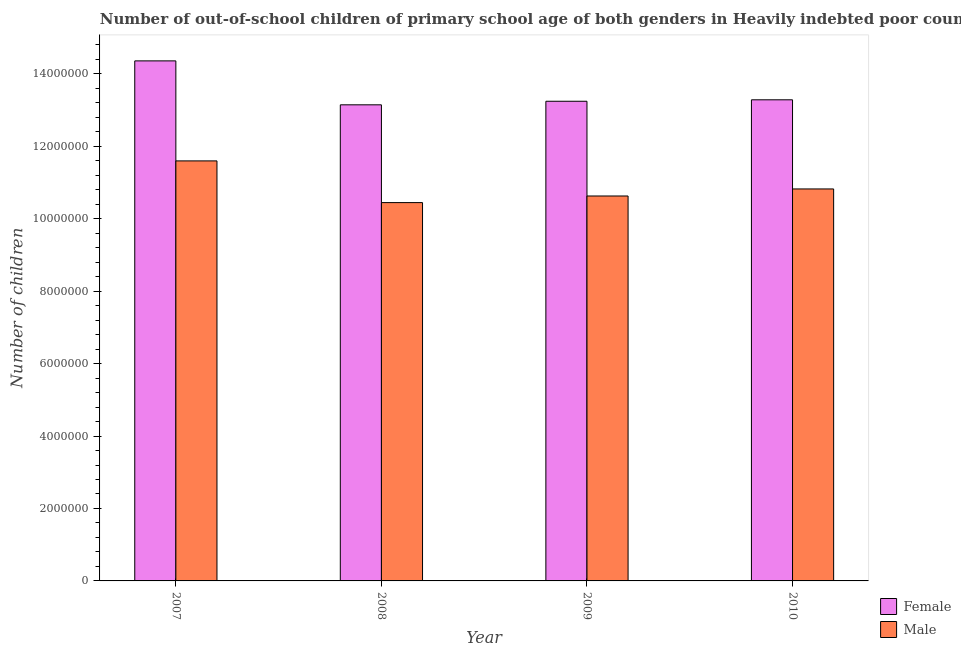How many groups of bars are there?
Offer a very short reply. 4. Are the number of bars per tick equal to the number of legend labels?
Keep it short and to the point. Yes. Are the number of bars on each tick of the X-axis equal?
Your answer should be compact. Yes. How many bars are there on the 3rd tick from the left?
Give a very brief answer. 2. What is the number of male out-of-school students in 2009?
Give a very brief answer. 1.06e+07. Across all years, what is the maximum number of male out-of-school students?
Make the answer very short. 1.16e+07. Across all years, what is the minimum number of male out-of-school students?
Offer a terse response. 1.04e+07. In which year was the number of male out-of-school students maximum?
Make the answer very short. 2007. What is the total number of female out-of-school students in the graph?
Offer a terse response. 5.40e+07. What is the difference between the number of male out-of-school students in 2007 and that in 2008?
Your response must be concise. 1.15e+06. What is the difference between the number of female out-of-school students in 2008 and the number of male out-of-school students in 2009?
Your answer should be very brief. -9.85e+04. What is the average number of female out-of-school students per year?
Provide a short and direct response. 1.35e+07. In the year 2008, what is the difference between the number of male out-of-school students and number of female out-of-school students?
Your response must be concise. 0. In how many years, is the number of female out-of-school students greater than 400000?
Ensure brevity in your answer.  4. What is the ratio of the number of male out-of-school students in 2007 to that in 2008?
Your answer should be very brief. 1.11. What is the difference between the highest and the second highest number of male out-of-school students?
Give a very brief answer. 7.74e+05. What is the difference between the highest and the lowest number of female out-of-school students?
Provide a short and direct response. 1.21e+06. In how many years, is the number of male out-of-school students greater than the average number of male out-of-school students taken over all years?
Make the answer very short. 1. Is the sum of the number of male out-of-school students in 2008 and 2009 greater than the maximum number of female out-of-school students across all years?
Make the answer very short. Yes. What does the 1st bar from the left in 2010 represents?
Your response must be concise. Female. How many bars are there?
Your answer should be compact. 8. How many years are there in the graph?
Provide a short and direct response. 4. What is the difference between two consecutive major ticks on the Y-axis?
Provide a succinct answer. 2.00e+06. Where does the legend appear in the graph?
Make the answer very short. Bottom right. What is the title of the graph?
Keep it short and to the point. Number of out-of-school children of primary school age of both genders in Heavily indebted poor countries. What is the label or title of the X-axis?
Ensure brevity in your answer.  Year. What is the label or title of the Y-axis?
Provide a succinct answer. Number of children. What is the Number of children of Female in 2007?
Keep it short and to the point. 1.44e+07. What is the Number of children of Male in 2007?
Offer a very short reply. 1.16e+07. What is the Number of children in Female in 2008?
Provide a succinct answer. 1.31e+07. What is the Number of children of Male in 2008?
Your response must be concise. 1.04e+07. What is the Number of children of Female in 2009?
Ensure brevity in your answer.  1.32e+07. What is the Number of children in Male in 2009?
Provide a short and direct response. 1.06e+07. What is the Number of children of Female in 2010?
Make the answer very short. 1.33e+07. What is the Number of children in Male in 2010?
Ensure brevity in your answer.  1.08e+07. Across all years, what is the maximum Number of children in Female?
Provide a succinct answer. 1.44e+07. Across all years, what is the maximum Number of children of Male?
Keep it short and to the point. 1.16e+07. Across all years, what is the minimum Number of children of Female?
Offer a very short reply. 1.31e+07. Across all years, what is the minimum Number of children of Male?
Give a very brief answer. 1.04e+07. What is the total Number of children of Female in the graph?
Provide a short and direct response. 5.40e+07. What is the total Number of children of Male in the graph?
Provide a short and direct response. 4.35e+07. What is the difference between the Number of children in Female in 2007 and that in 2008?
Ensure brevity in your answer.  1.21e+06. What is the difference between the Number of children of Male in 2007 and that in 2008?
Ensure brevity in your answer.  1.15e+06. What is the difference between the Number of children of Female in 2007 and that in 2009?
Keep it short and to the point. 1.11e+06. What is the difference between the Number of children of Male in 2007 and that in 2009?
Ensure brevity in your answer.  9.69e+05. What is the difference between the Number of children of Female in 2007 and that in 2010?
Offer a terse response. 1.07e+06. What is the difference between the Number of children in Male in 2007 and that in 2010?
Your response must be concise. 7.74e+05. What is the difference between the Number of children in Female in 2008 and that in 2009?
Ensure brevity in your answer.  -9.85e+04. What is the difference between the Number of children of Male in 2008 and that in 2009?
Your answer should be compact. -1.83e+05. What is the difference between the Number of children of Female in 2008 and that in 2010?
Provide a short and direct response. -1.38e+05. What is the difference between the Number of children in Male in 2008 and that in 2010?
Your answer should be very brief. -3.77e+05. What is the difference between the Number of children in Female in 2009 and that in 2010?
Keep it short and to the point. -4.00e+04. What is the difference between the Number of children in Male in 2009 and that in 2010?
Keep it short and to the point. -1.95e+05. What is the difference between the Number of children of Female in 2007 and the Number of children of Male in 2008?
Your response must be concise. 3.91e+06. What is the difference between the Number of children of Female in 2007 and the Number of children of Male in 2009?
Offer a terse response. 3.73e+06. What is the difference between the Number of children in Female in 2007 and the Number of children in Male in 2010?
Offer a very short reply. 3.54e+06. What is the difference between the Number of children of Female in 2008 and the Number of children of Male in 2009?
Offer a very short reply. 2.52e+06. What is the difference between the Number of children in Female in 2008 and the Number of children in Male in 2010?
Your answer should be very brief. 2.32e+06. What is the difference between the Number of children of Female in 2009 and the Number of children of Male in 2010?
Give a very brief answer. 2.42e+06. What is the average Number of children in Female per year?
Provide a succinct answer. 1.35e+07. What is the average Number of children of Male per year?
Your answer should be compact. 1.09e+07. In the year 2007, what is the difference between the Number of children of Female and Number of children of Male?
Provide a succinct answer. 2.76e+06. In the year 2008, what is the difference between the Number of children in Female and Number of children in Male?
Keep it short and to the point. 2.70e+06. In the year 2009, what is the difference between the Number of children of Female and Number of children of Male?
Provide a succinct answer. 2.62e+06. In the year 2010, what is the difference between the Number of children in Female and Number of children in Male?
Your response must be concise. 2.46e+06. What is the ratio of the Number of children in Female in 2007 to that in 2008?
Your answer should be compact. 1.09. What is the ratio of the Number of children of Male in 2007 to that in 2008?
Your response must be concise. 1.11. What is the ratio of the Number of children in Female in 2007 to that in 2009?
Your answer should be very brief. 1.08. What is the ratio of the Number of children of Male in 2007 to that in 2009?
Give a very brief answer. 1.09. What is the ratio of the Number of children of Female in 2007 to that in 2010?
Offer a very short reply. 1.08. What is the ratio of the Number of children in Male in 2007 to that in 2010?
Ensure brevity in your answer.  1.07. What is the ratio of the Number of children of Female in 2008 to that in 2009?
Your response must be concise. 0.99. What is the ratio of the Number of children in Male in 2008 to that in 2009?
Offer a terse response. 0.98. What is the ratio of the Number of children of Male in 2008 to that in 2010?
Offer a very short reply. 0.97. What is the difference between the highest and the second highest Number of children of Female?
Your answer should be very brief. 1.07e+06. What is the difference between the highest and the second highest Number of children of Male?
Provide a short and direct response. 7.74e+05. What is the difference between the highest and the lowest Number of children of Female?
Your answer should be very brief. 1.21e+06. What is the difference between the highest and the lowest Number of children of Male?
Your answer should be very brief. 1.15e+06. 